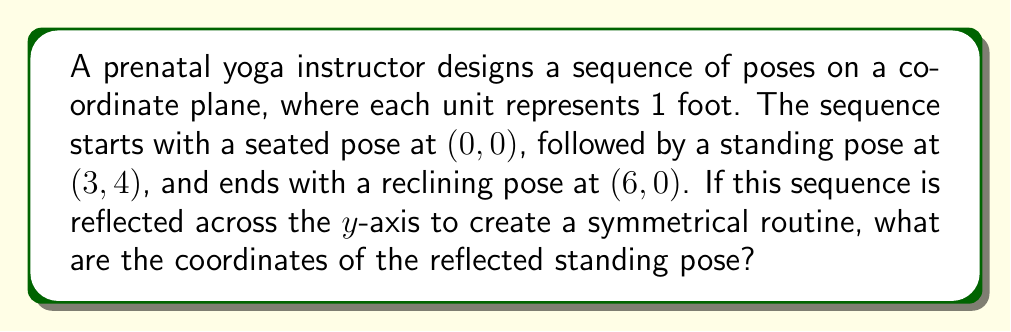Can you answer this question? To solve this problem, we'll follow these steps:

1) First, let's visualize the original sequence:
   [asy]
   unitsize(0.5cm);
   dot((0,0));
   dot((3,4));
   dot((6,0));
   draw((0,0)--(3,4)--(6,0), arrow=Arrow(TeXHead));
   label("(0,0)", (0,0), SW);
   label("(3,4)", (3,4), NE);
   label("(6,0)", (6,0), SE);
   draw((-7,0)--(7,0), arrow=Arrow(TeXHead));
   draw((0,-1)--(0,5), arrow=Arrow(TeXHead));
   label("x", (7,0), E);
   label("y", (0,5), N);
   [/asy]

2) To reflect across the y-axis, we need to change the sign of the x-coordinate while keeping the y-coordinate the same.

3) For the standing pose at (3, 4):
   - The x-coordinate changes from 3 to -3
   - The y-coordinate remains 4

4) Therefore, the reflected standing pose will be at (-3, 4).

5) We can verify this by imagining the entire sequence reflected:
   [asy]
   unitsize(0.5cm);
   dot((0,0));
   dot((3,4));
   dot((6,0));
   dot((-3,4));
   dot((-6,0));
   draw((0,0)--(3,4)--(6,0), arrow=Arrow(TeXHead));
   draw((0,0)--(-3,4)--(-6,0), arrow=Arrow(TeXHead));
   label("(0,0)", (0,0), S);
   label("(3,4)", (3,4), NE);
   label("(6,0)", (6,0), SE);
   label("(-3,4)", (-3,4), NW);
   label("(-6,0)", (-6,0), SW);
   draw((-7,0)--(7,0), arrow=Arrow(TeXHead));
   draw((0,-1)--(0,5), arrow=Arrow(TeXHead));
   label("x", (7,0), E);
   label("y", (0,5), N);
   [/asy]
Answer: $(-3, 4)$ 